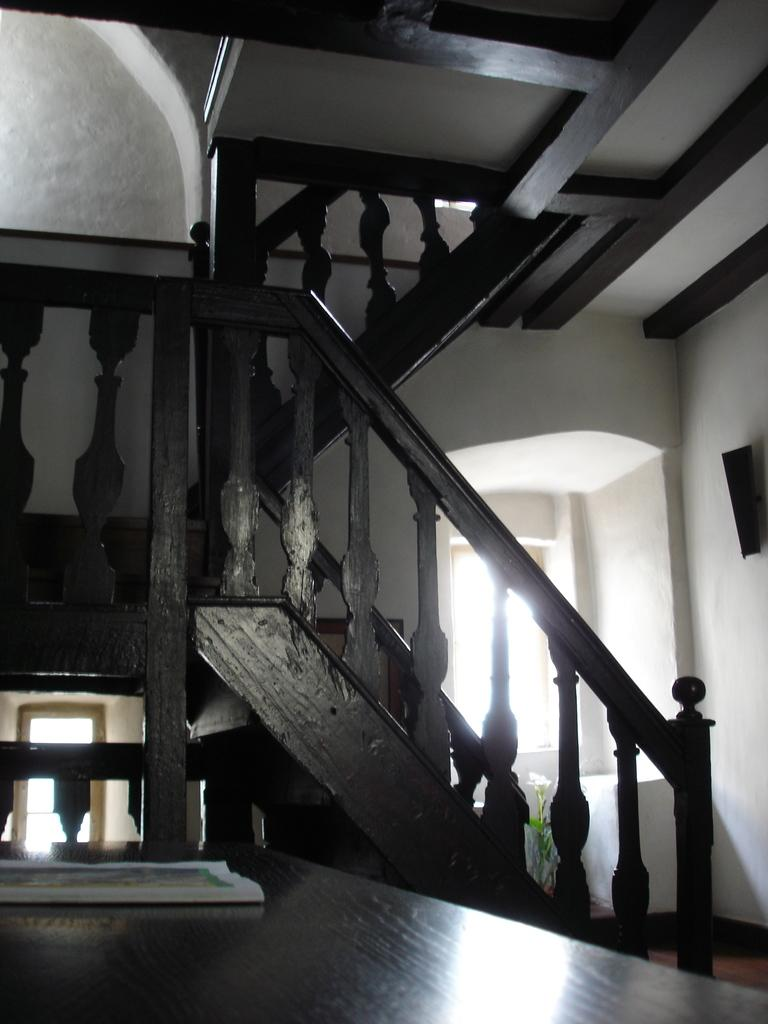What is present on the table in the image? There is a book on the table in the image. What architectural feature can be seen in the image? There is a staircase in the image. What type of structure is visible in the image? There is a wall in the image. Can you describe the bee that is twisting around the cream in the image? There is no bee or cream present in the image. The conversation focuses on the table, book, staircase, and wall, as described in the provided facts. 